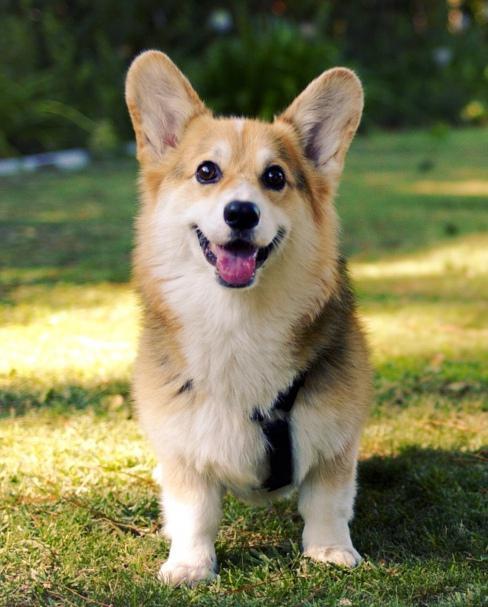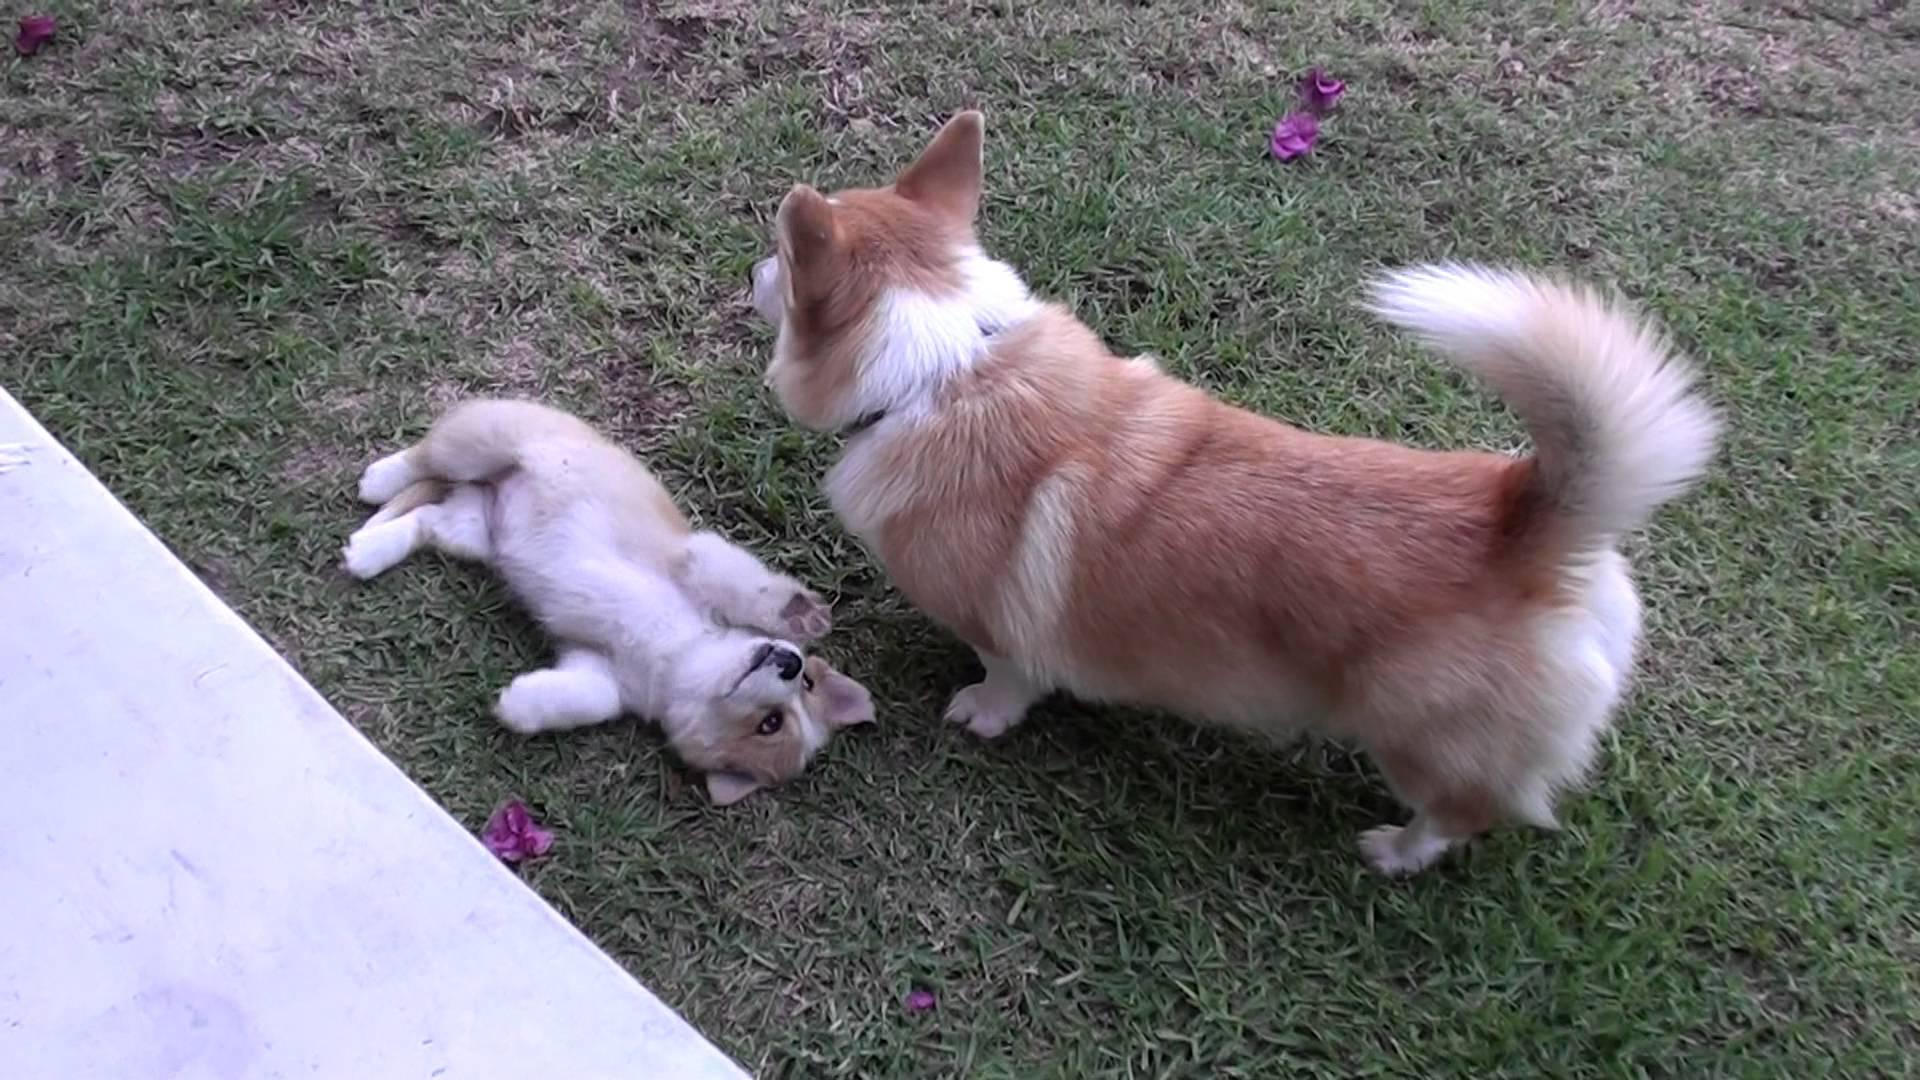The first image is the image on the left, the second image is the image on the right. For the images displayed, is the sentence "There are 3 dogs outdoors on the grass." factually correct? Answer yes or no. Yes. The first image is the image on the left, the second image is the image on the right. Evaluate the accuracy of this statement regarding the images: "Three dogs are visible.". Is it true? Answer yes or no. Yes. 